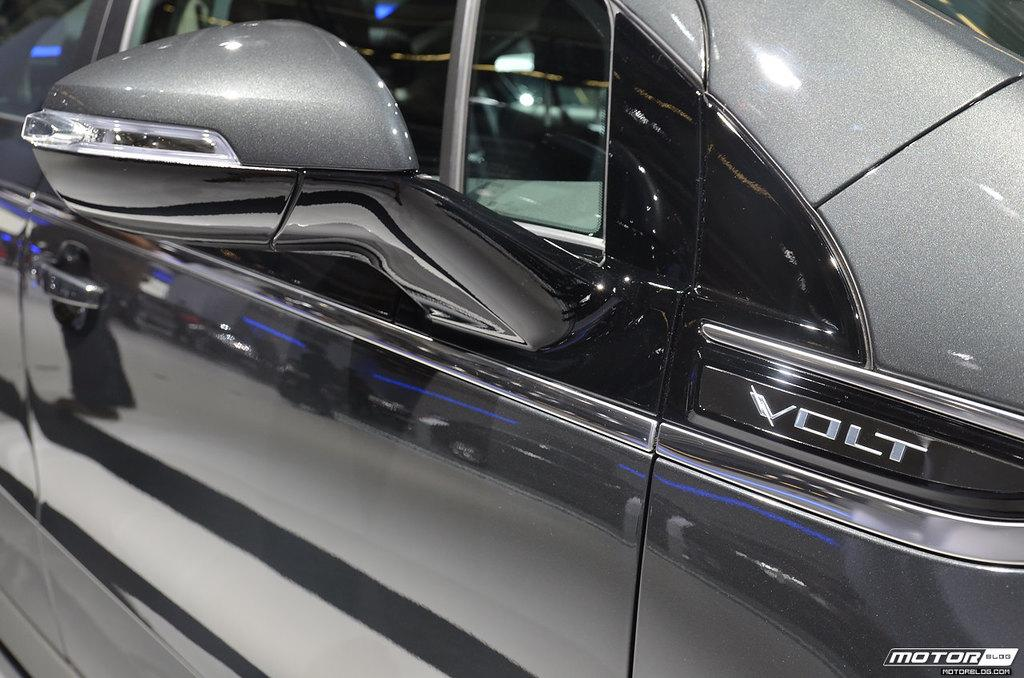What is the main subject of the image? The main subject of the image is a car. What features can be seen on the car? The car has a door and a mirror. Is there any identification on the car? Yes, there is a name on the car. What else is present in the image besides the car? There is text in the bottom right corner of the image. Can you tell me how many scarecrows are standing next to the car in the image? There are no scarecrows present in the image; it features a car with specific features and identification. What type of cake is being served on the car's hood in the image? There is no cake present in the image; it only features a car with a door, mirror, name, and text in the bottom right corner. 